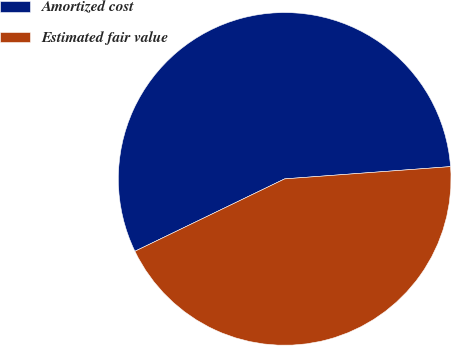Convert chart. <chart><loc_0><loc_0><loc_500><loc_500><pie_chart><fcel>Amortized cost<fcel>Estimated fair value<nl><fcel>55.99%<fcel>44.01%<nl></chart> 